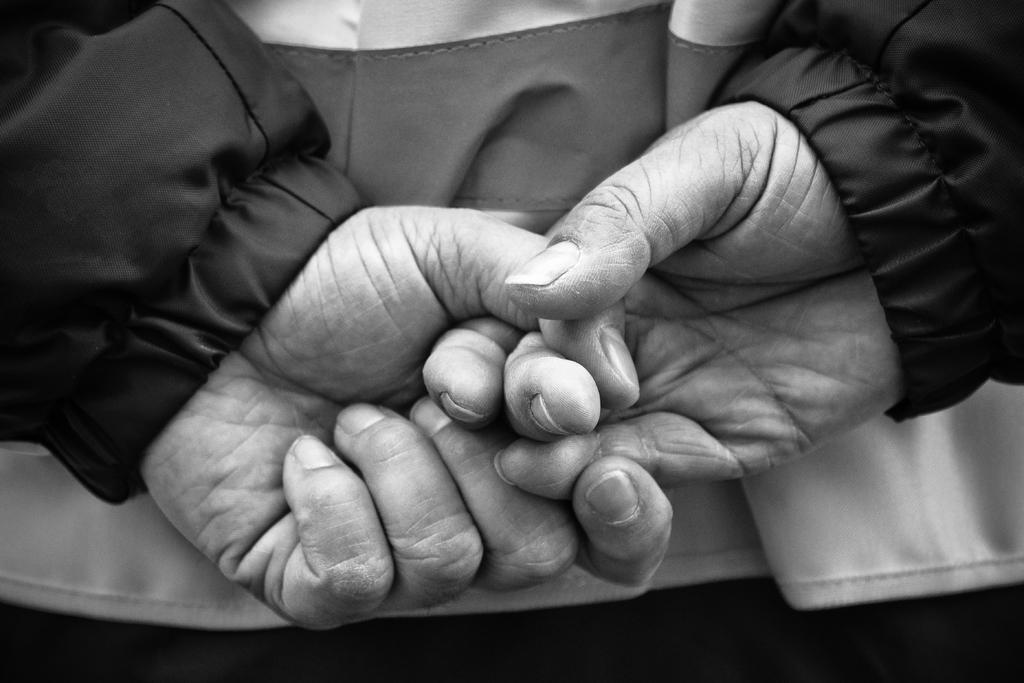What is the main subject of the image? There is a person in the image. What part of the person's body is visible in the center of the image? The person's hands are visible in the center of the image. What type of clothing is the person wearing? The person is wearing a coat. What type of glass is the person holding in the image? There is no glass present in the image; the person's hands are visible in the center of the image, but they are not holding anything. What type of thread is the person using to sew in the image? There is no thread or sewing activity present in the image; the person is simply wearing a coat. 